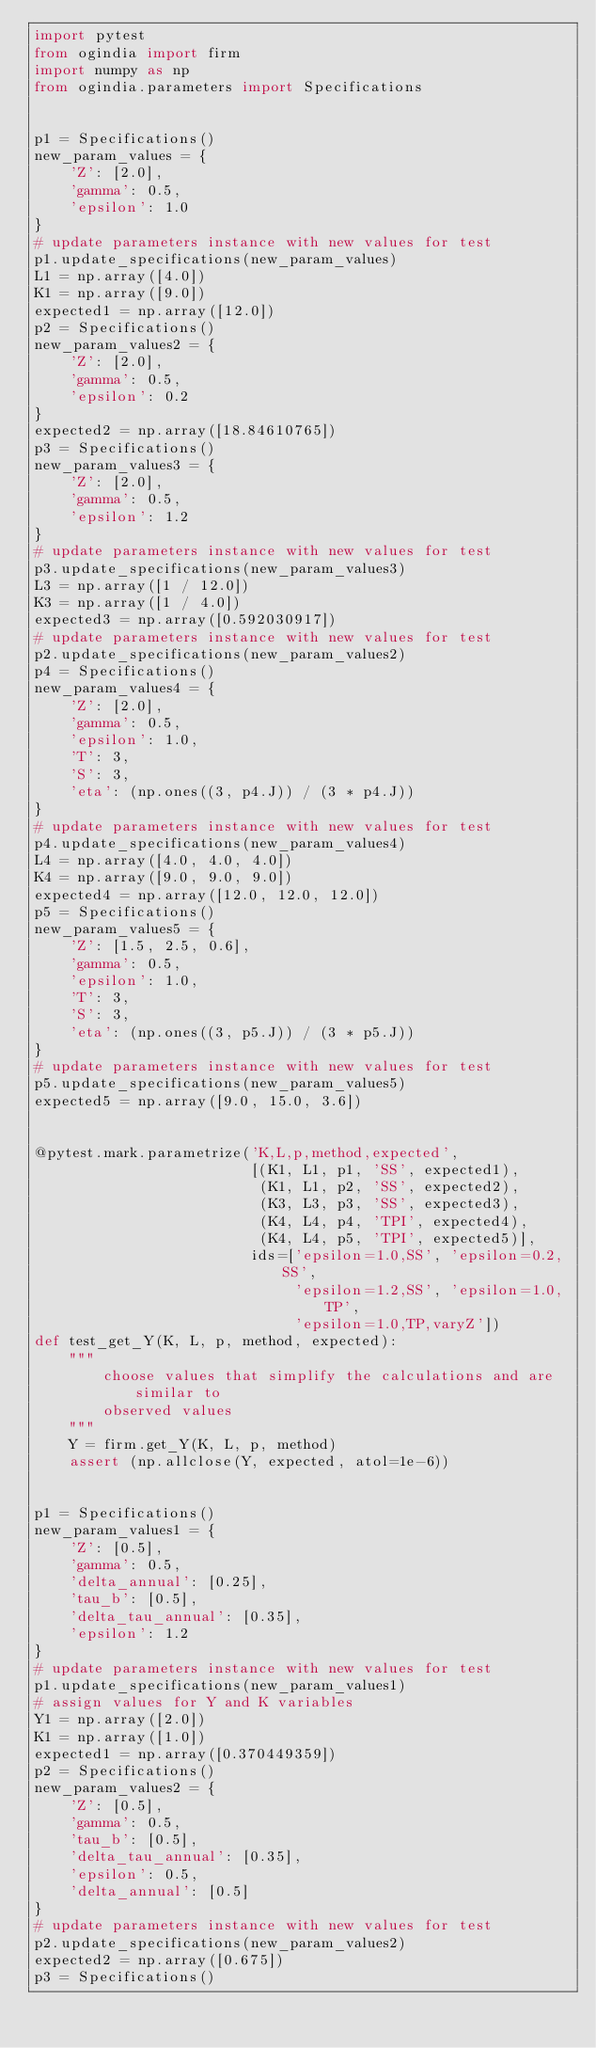Convert code to text. <code><loc_0><loc_0><loc_500><loc_500><_Python_>import pytest
from ogindia import firm
import numpy as np
from ogindia.parameters import Specifications


p1 = Specifications()
new_param_values = {
    'Z': [2.0],
    'gamma': 0.5,
    'epsilon': 1.0
}
# update parameters instance with new values for test
p1.update_specifications(new_param_values)
L1 = np.array([4.0])
K1 = np.array([9.0])
expected1 = np.array([12.0])
p2 = Specifications()
new_param_values2 = {
    'Z': [2.0],
    'gamma': 0.5,
    'epsilon': 0.2
}
expected2 = np.array([18.84610765])
p3 = Specifications()
new_param_values3 = {
    'Z': [2.0],
    'gamma': 0.5,
    'epsilon': 1.2
}
# update parameters instance with new values for test
p3.update_specifications(new_param_values3)
L3 = np.array([1 / 12.0])
K3 = np.array([1 / 4.0])
expected3 = np.array([0.592030917])
# update parameters instance with new values for test
p2.update_specifications(new_param_values2)
p4 = Specifications()
new_param_values4 = {
    'Z': [2.0],
    'gamma': 0.5,
    'epsilon': 1.0,
    'T': 3,
    'S': 3,
    'eta': (np.ones((3, p4.J)) / (3 * p4.J))
}
# update parameters instance with new values for test
p4.update_specifications(new_param_values4)
L4 = np.array([4.0, 4.0, 4.0])
K4 = np.array([9.0, 9.0, 9.0])
expected4 = np.array([12.0, 12.0, 12.0])
p5 = Specifications()
new_param_values5 = {
    'Z': [1.5, 2.5, 0.6],
    'gamma': 0.5,
    'epsilon': 1.0,
    'T': 3,
    'S': 3,
    'eta': (np.ones((3, p5.J)) / (3 * p5.J))
}
# update parameters instance with new values for test
p5.update_specifications(new_param_values5)
expected5 = np.array([9.0, 15.0, 3.6])


@pytest.mark.parametrize('K,L,p,method,expected',
                         [(K1, L1, p1, 'SS', expected1),
                          (K1, L1, p2, 'SS', expected2),
                          (K3, L3, p3, 'SS', expected3),
                          (K4, L4, p4, 'TPI', expected4),
                          (K4, L4, p5, 'TPI', expected5)],
                         ids=['epsilon=1.0,SS', 'epsilon=0.2,SS',
                              'epsilon=1.2,SS', 'epsilon=1.0,TP',
                              'epsilon=1.0,TP,varyZ'])
def test_get_Y(K, L, p, method, expected):
    """
        choose values that simplify the calculations and are similar to
        observed values
    """
    Y = firm.get_Y(K, L, p, method)
    assert (np.allclose(Y, expected, atol=1e-6))


p1 = Specifications()
new_param_values1 = {
    'Z': [0.5],
    'gamma': 0.5,
    'delta_annual': [0.25],
    'tau_b': [0.5],
    'delta_tau_annual': [0.35],
    'epsilon': 1.2
}
# update parameters instance with new values for test
p1.update_specifications(new_param_values1)
# assign values for Y and K variables
Y1 = np.array([2.0])
K1 = np.array([1.0])
expected1 = np.array([0.370449359])
p2 = Specifications()
new_param_values2 = {
    'Z': [0.5],
    'gamma': 0.5,
    'tau_b': [0.5],
    'delta_tau_annual': [0.35],
    'epsilon': 0.5,
    'delta_annual': [0.5]
}
# update parameters instance with new values for test
p2.update_specifications(new_param_values2)
expected2 = np.array([0.675])
p3 = Specifications()</code> 